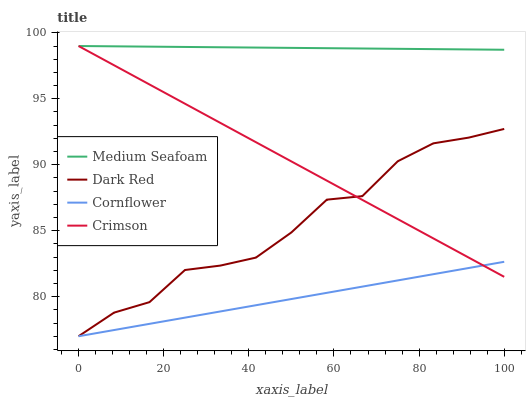Does Dark Red have the minimum area under the curve?
Answer yes or no. No. Does Dark Red have the maximum area under the curve?
Answer yes or no. No. Is Medium Seafoam the smoothest?
Answer yes or no. No. Is Medium Seafoam the roughest?
Answer yes or no. No. Does Medium Seafoam have the lowest value?
Answer yes or no. No. Does Dark Red have the highest value?
Answer yes or no. No. Is Dark Red less than Medium Seafoam?
Answer yes or no. Yes. Is Medium Seafoam greater than Cornflower?
Answer yes or no. Yes. Does Dark Red intersect Medium Seafoam?
Answer yes or no. No. 